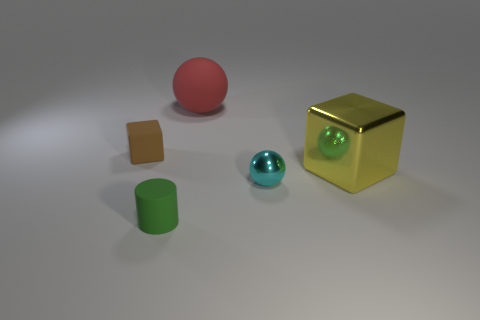What material is the tiny cyan ball?
Your answer should be very brief. Metal. Is the sphere behind the small cyan ball made of the same material as the cyan ball?
Ensure brevity in your answer.  No. The large thing that is on the left side of the big yellow block has what shape?
Provide a succinct answer. Sphere. What is the material of the brown block that is the same size as the green matte cylinder?
Provide a succinct answer. Rubber. What number of things are either small objects that are behind the green object or big objects that are to the right of the large red thing?
Offer a terse response. 3. The object that is the same material as the yellow block is what size?
Your response must be concise. Small. What number of rubber objects are either big balls or big brown cubes?
Provide a succinct answer. 1. The yellow shiny thing has what size?
Offer a terse response. Large. Do the shiny ball and the matte ball have the same size?
Ensure brevity in your answer.  No. What is the material of the sphere that is in front of the yellow object?
Provide a short and direct response. Metal. 